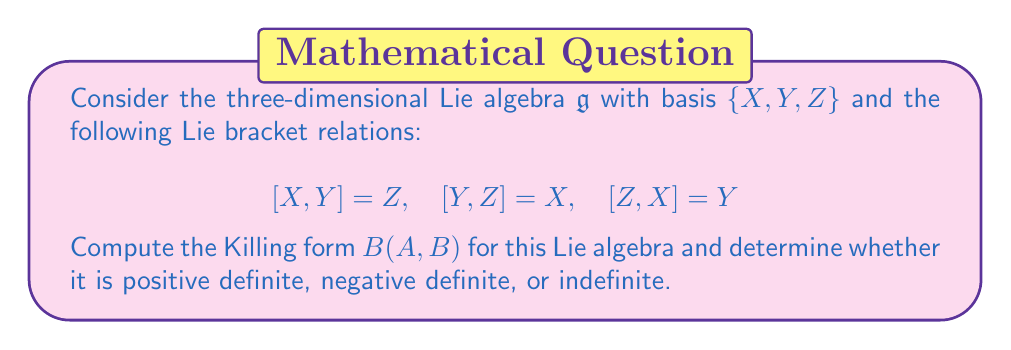Solve this math problem. Let's approach this step-by-step:

1) The Killing form is defined as $B(A,B) = \text{tr}(\text{ad}_A \circ \text{ad}_B)$, where $\text{ad}_A$ is the adjoint representation of $A$.

2) First, we need to find the matrix representations of $\text{ad}_X$, $\text{ad}_Y$, and $\text{ad}_Z$:

   For $\text{ad}_X$: 
   $$\text{ad}_X(X) = 0, \quad \text{ad}_X(Y) = Z, \quad \text{ad}_X(Z) = -Y$$
   So, $\text{ad}_X = \begin{pmatrix} 0 & 0 & 0 \\ 0 & 0 & -1 \\ 0 & 1 & 0 \end{pmatrix}$

   Similarly,
   $\text{ad}_Y = \begin{pmatrix} 0 & 0 & 1 \\ 0 & 0 & 0 \\ -1 & 0 & 0 \end{pmatrix}$
   
   $\text{ad}_Z = \begin{pmatrix} 0 & -1 & 0 \\ 1 & 0 & 0 \\ 0 & 0 & 0 \end{pmatrix}$

3) Now, we can compute $B(X,X)$, $B(Y,Y)$, and $B(Z,Z)$:

   $B(X,X) = \text{tr}(\text{ad}_X \circ \text{ad}_X) = \text{tr}\begin{pmatrix} 0 & 0 & 0 \\ 0 & -1 & 0 \\ 0 & 0 & -1 \end{pmatrix} = -2$

   Similarly, $B(Y,Y) = B(Z,Z) = -2$

4) For the off-diagonal elements:

   $B(X,Y) = \text{tr}(\text{ad}_X \circ \text{ad}_Y) = \text{tr}\begin{pmatrix} 0 & 0 & 0 \\ 0 & 0 & 0 \\ 0 & 0 & 0 \end{pmatrix} = 0$

   Similarly, $B(X,Z) = B(Y,Z) = 0$

5) Therefore, the Killing form matrix is:

   $$B = \begin{pmatrix} -2 & 0 & 0 \\ 0 & -2 & 0 \\ 0 & 0 & -2 \end{pmatrix}$$

6) To determine its definiteness, we look at its eigenvalues. All eigenvalues are -2, which are negative.
Answer: The Killing form for the given Lie algebra is $B = \text{diag}(-2,-2,-2)$. It is negative definite as all its eigenvalues are negative. 